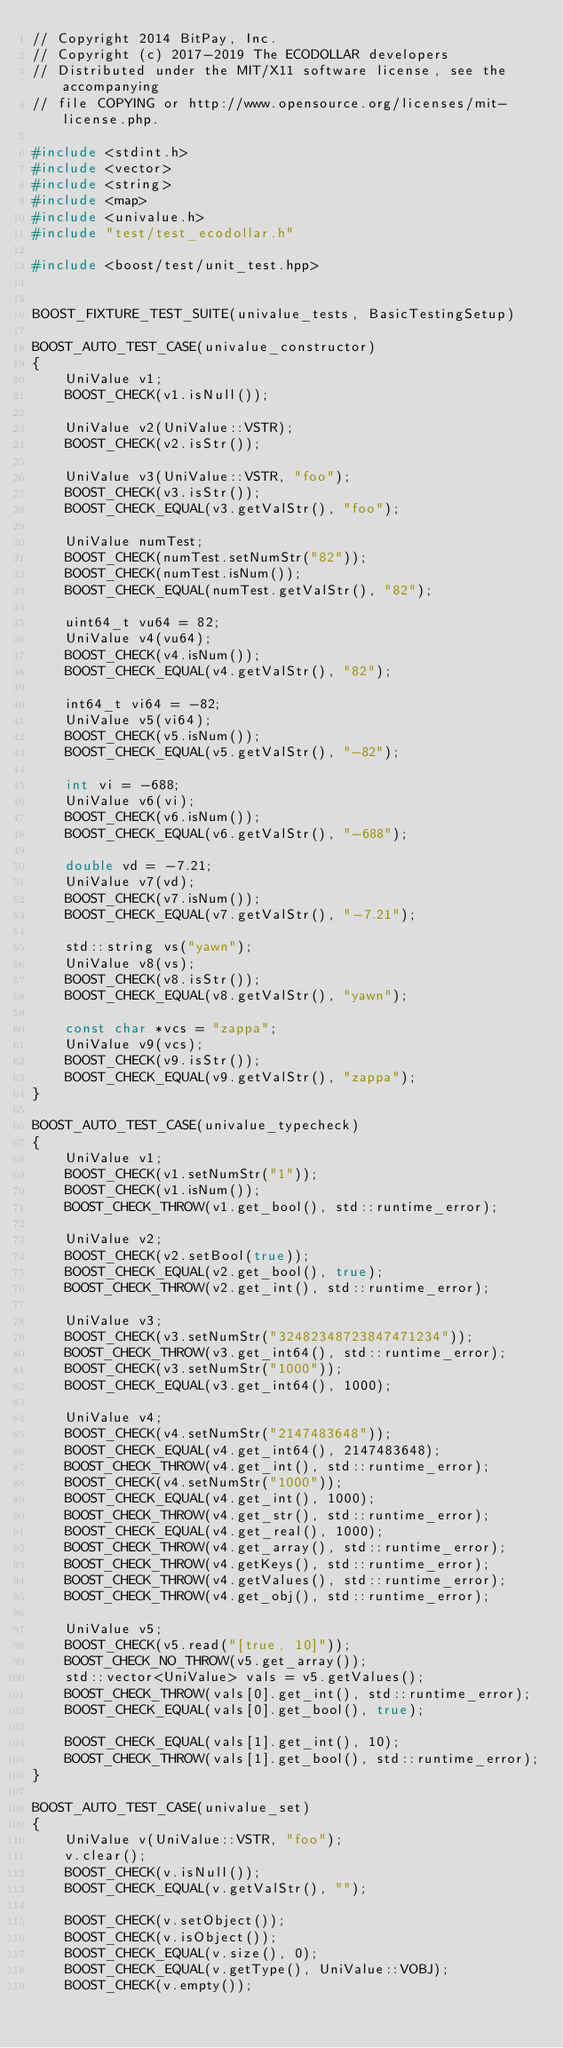<code> <loc_0><loc_0><loc_500><loc_500><_C++_>// Copyright 2014 BitPay, Inc.
// Copyright (c) 2017-2019 The ECODOLLAR developers
// Distributed under the MIT/X11 software license, see the accompanying
// file COPYING or http://www.opensource.org/licenses/mit-license.php.

#include <stdint.h>
#include <vector>
#include <string>
#include <map>
#include <univalue.h>
#include "test/test_ecodollar.h"

#include <boost/test/unit_test.hpp>


BOOST_FIXTURE_TEST_SUITE(univalue_tests, BasicTestingSetup)

BOOST_AUTO_TEST_CASE(univalue_constructor)
{
    UniValue v1;
    BOOST_CHECK(v1.isNull());

    UniValue v2(UniValue::VSTR);
    BOOST_CHECK(v2.isStr());

    UniValue v3(UniValue::VSTR, "foo");
    BOOST_CHECK(v3.isStr());
    BOOST_CHECK_EQUAL(v3.getValStr(), "foo");

    UniValue numTest;
    BOOST_CHECK(numTest.setNumStr("82"));
    BOOST_CHECK(numTest.isNum());
    BOOST_CHECK_EQUAL(numTest.getValStr(), "82");

    uint64_t vu64 = 82;
    UniValue v4(vu64);
    BOOST_CHECK(v4.isNum());
    BOOST_CHECK_EQUAL(v4.getValStr(), "82");

    int64_t vi64 = -82;
    UniValue v5(vi64);
    BOOST_CHECK(v5.isNum());
    BOOST_CHECK_EQUAL(v5.getValStr(), "-82");

    int vi = -688;
    UniValue v6(vi);
    BOOST_CHECK(v6.isNum());
    BOOST_CHECK_EQUAL(v6.getValStr(), "-688");

    double vd = -7.21;
    UniValue v7(vd);
    BOOST_CHECK(v7.isNum());
    BOOST_CHECK_EQUAL(v7.getValStr(), "-7.21");

    std::string vs("yawn");
    UniValue v8(vs);
    BOOST_CHECK(v8.isStr());
    BOOST_CHECK_EQUAL(v8.getValStr(), "yawn");

    const char *vcs = "zappa";
    UniValue v9(vcs);
    BOOST_CHECK(v9.isStr());
    BOOST_CHECK_EQUAL(v9.getValStr(), "zappa");
}

BOOST_AUTO_TEST_CASE(univalue_typecheck)
{
    UniValue v1;
    BOOST_CHECK(v1.setNumStr("1"));
    BOOST_CHECK(v1.isNum());
    BOOST_CHECK_THROW(v1.get_bool(), std::runtime_error);

    UniValue v2;
    BOOST_CHECK(v2.setBool(true));
    BOOST_CHECK_EQUAL(v2.get_bool(), true);
    BOOST_CHECK_THROW(v2.get_int(), std::runtime_error);

    UniValue v3;
    BOOST_CHECK(v3.setNumStr("32482348723847471234"));
    BOOST_CHECK_THROW(v3.get_int64(), std::runtime_error);
    BOOST_CHECK(v3.setNumStr("1000"));
    BOOST_CHECK_EQUAL(v3.get_int64(), 1000);

    UniValue v4;
    BOOST_CHECK(v4.setNumStr("2147483648"));
    BOOST_CHECK_EQUAL(v4.get_int64(), 2147483648);
    BOOST_CHECK_THROW(v4.get_int(), std::runtime_error);
    BOOST_CHECK(v4.setNumStr("1000"));
    BOOST_CHECK_EQUAL(v4.get_int(), 1000);
    BOOST_CHECK_THROW(v4.get_str(), std::runtime_error);
    BOOST_CHECK_EQUAL(v4.get_real(), 1000);
    BOOST_CHECK_THROW(v4.get_array(), std::runtime_error);
    BOOST_CHECK_THROW(v4.getKeys(), std::runtime_error);
    BOOST_CHECK_THROW(v4.getValues(), std::runtime_error);
    BOOST_CHECK_THROW(v4.get_obj(), std::runtime_error);

    UniValue v5;
    BOOST_CHECK(v5.read("[true, 10]"));
    BOOST_CHECK_NO_THROW(v5.get_array());
    std::vector<UniValue> vals = v5.getValues();
    BOOST_CHECK_THROW(vals[0].get_int(), std::runtime_error);
    BOOST_CHECK_EQUAL(vals[0].get_bool(), true);

    BOOST_CHECK_EQUAL(vals[1].get_int(), 10);
    BOOST_CHECK_THROW(vals[1].get_bool(), std::runtime_error);
}

BOOST_AUTO_TEST_CASE(univalue_set)
{
    UniValue v(UniValue::VSTR, "foo");
    v.clear();
    BOOST_CHECK(v.isNull());
    BOOST_CHECK_EQUAL(v.getValStr(), "");

    BOOST_CHECK(v.setObject());
    BOOST_CHECK(v.isObject());
    BOOST_CHECK_EQUAL(v.size(), 0);
    BOOST_CHECK_EQUAL(v.getType(), UniValue::VOBJ);
    BOOST_CHECK(v.empty());
</code> 